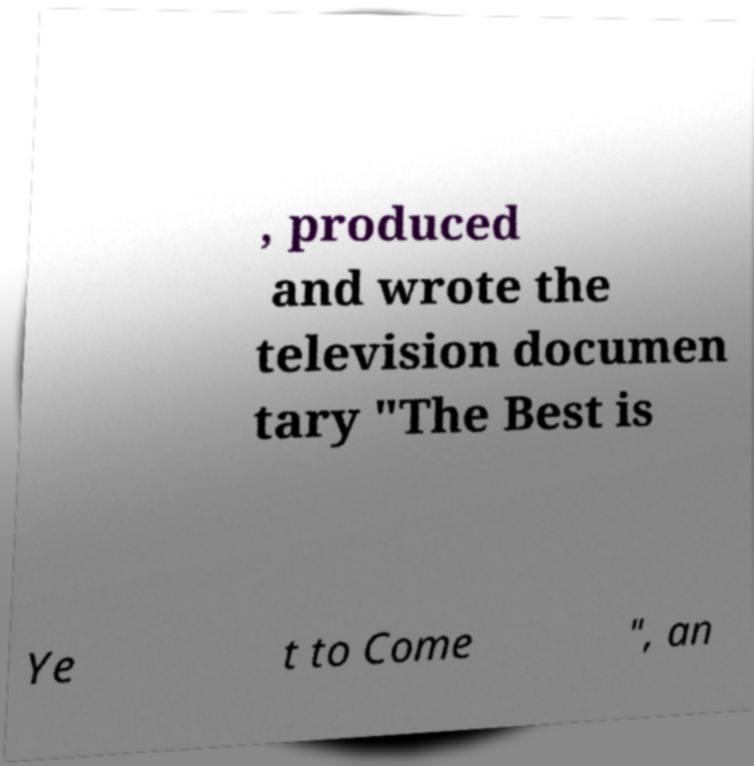Please identify and transcribe the text found in this image. , produced and wrote the television documen tary "The Best is Ye t to Come ", an 